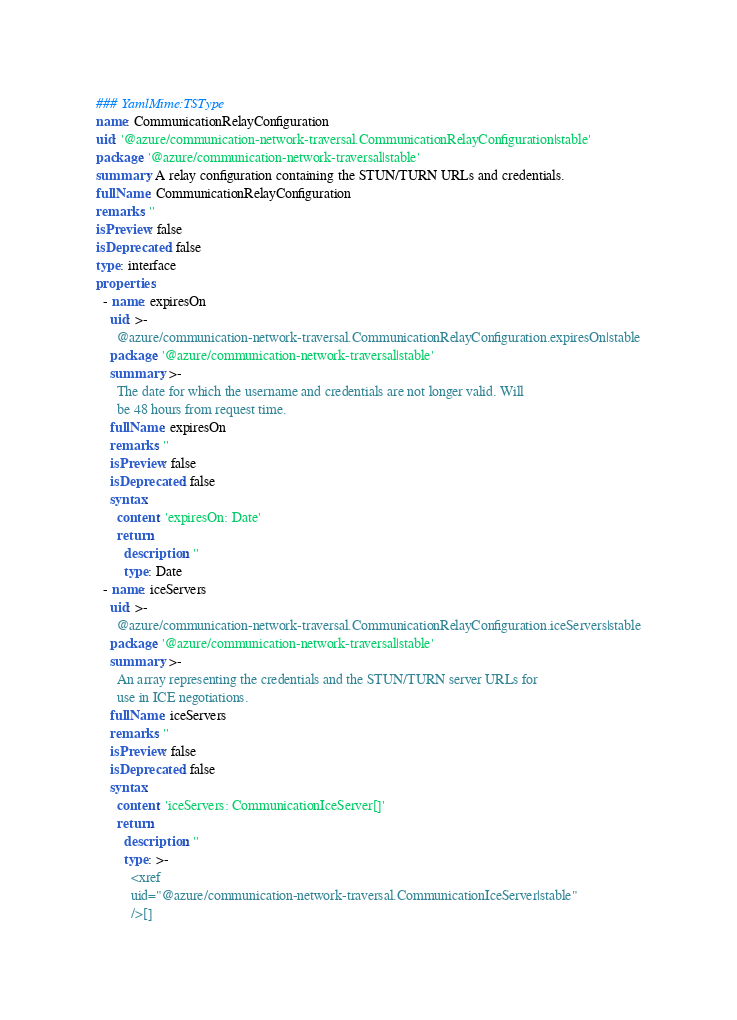<code> <loc_0><loc_0><loc_500><loc_500><_YAML_>### YamlMime:TSType
name: CommunicationRelayConfiguration
uid: '@azure/communication-network-traversal.CommunicationRelayConfiguration|stable'
package: '@azure/communication-network-traversal|stable'
summary: A relay configuration containing the STUN/TURN URLs and credentials.
fullName: CommunicationRelayConfiguration
remarks: ''
isPreview: false
isDeprecated: false
type: interface
properties:
  - name: expiresOn
    uid: >-
      @azure/communication-network-traversal.CommunicationRelayConfiguration.expiresOn|stable
    package: '@azure/communication-network-traversal|stable'
    summary: >-
      The date for which the username and credentials are not longer valid. Will
      be 48 hours from request time.
    fullName: expiresOn
    remarks: ''
    isPreview: false
    isDeprecated: false
    syntax:
      content: 'expiresOn: Date'
      return:
        description: ''
        type: Date
  - name: iceServers
    uid: >-
      @azure/communication-network-traversal.CommunicationRelayConfiguration.iceServers|stable
    package: '@azure/communication-network-traversal|stable'
    summary: >-
      An array representing the credentials and the STUN/TURN server URLs for
      use in ICE negotiations.
    fullName: iceServers
    remarks: ''
    isPreview: false
    isDeprecated: false
    syntax:
      content: 'iceServers: CommunicationIceServer[]'
      return:
        description: ''
        type: >-
          <xref
          uid="@azure/communication-network-traversal.CommunicationIceServer|stable"
          />[]
</code> 